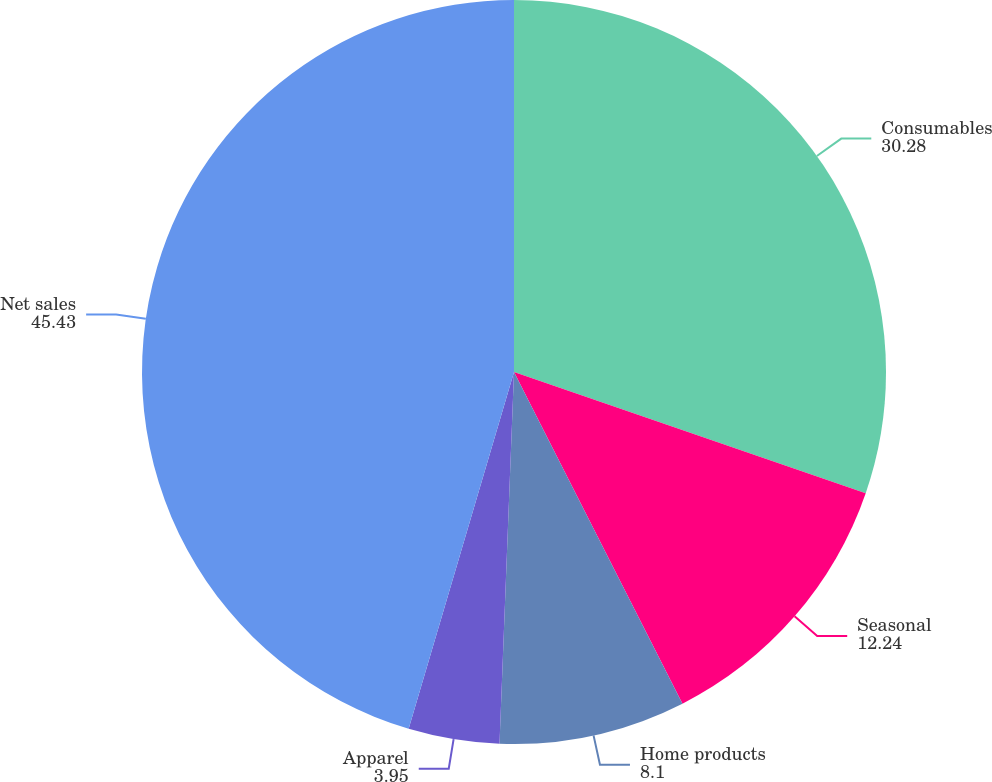<chart> <loc_0><loc_0><loc_500><loc_500><pie_chart><fcel>Consumables<fcel>Seasonal<fcel>Home products<fcel>Apparel<fcel>Net sales<nl><fcel>30.28%<fcel>12.24%<fcel>8.1%<fcel>3.95%<fcel>45.43%<nl></chart> 